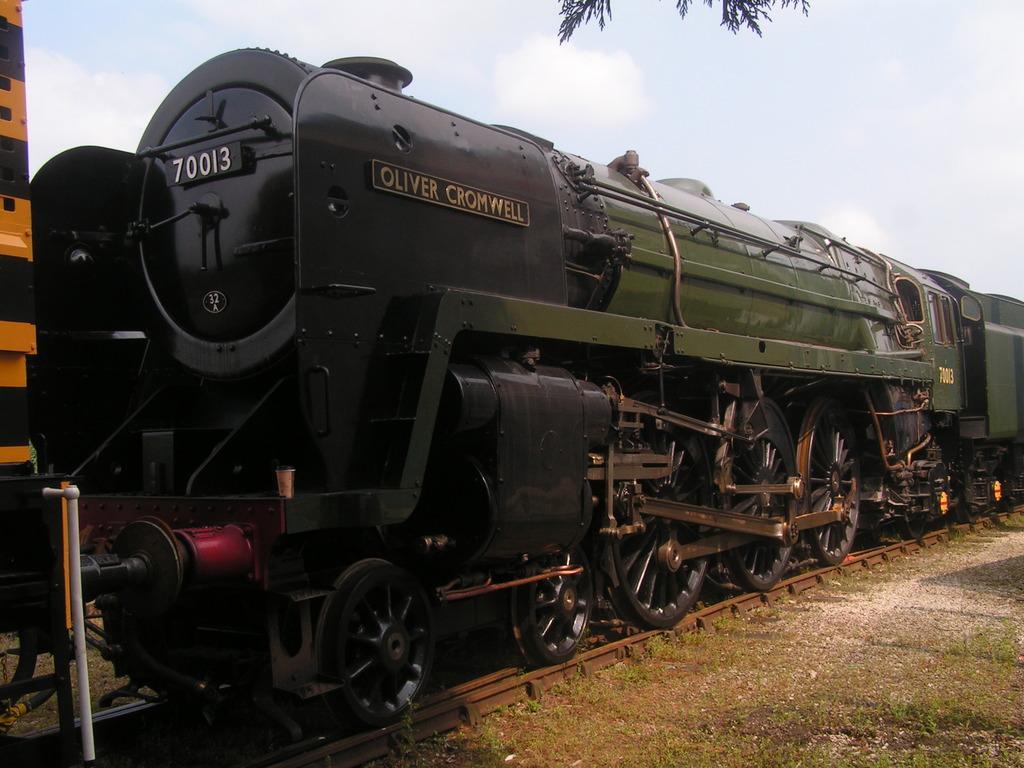Can you describe this image briefly? Here in this picture we can see a train present on the railway track over there and we can see the ground is fully covered with grass over there and at the top we can see leaves of a tree hanging and we can see clouds in the sky over there. 